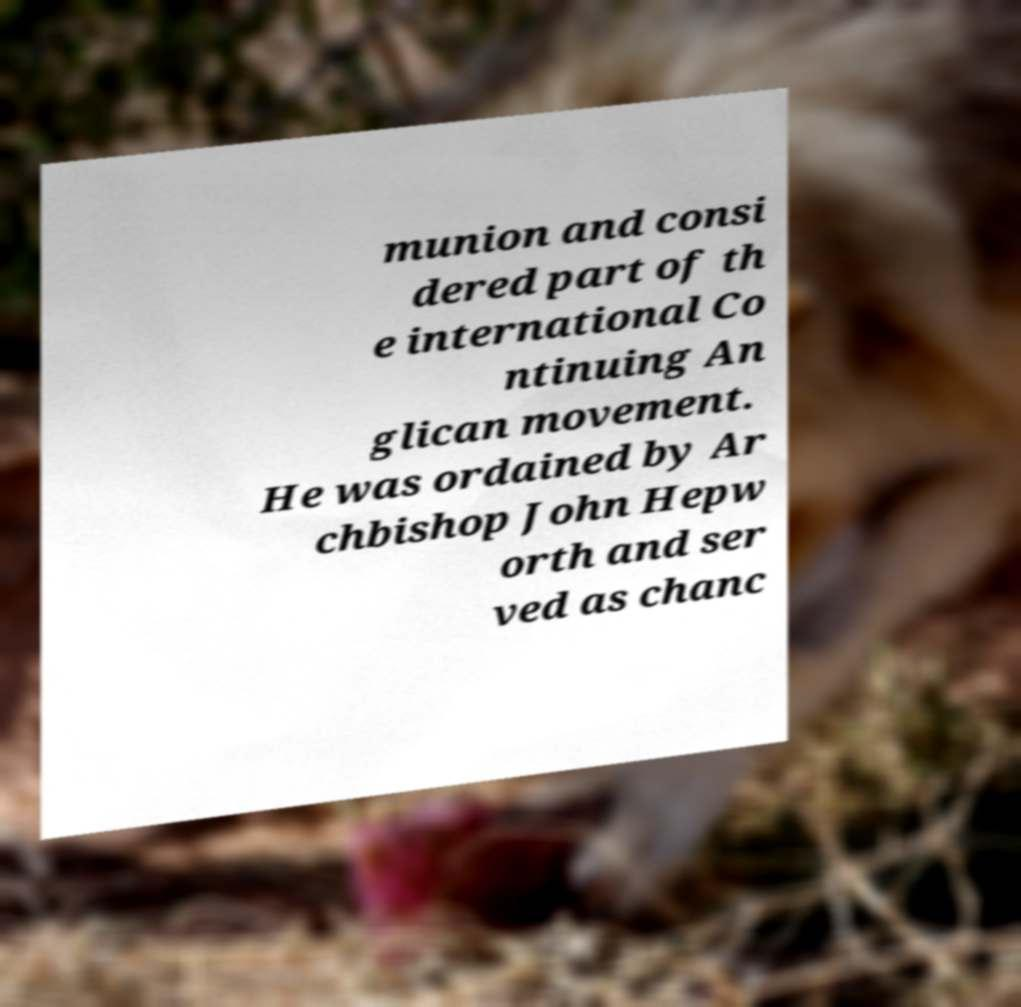Can you accurately transcribe the text from the provided image for me? munion and consi dered part of th e international Co ntinuing An glican movement. He was ordained by Ar chbishop John Hepw orth and ser ved as chanc 